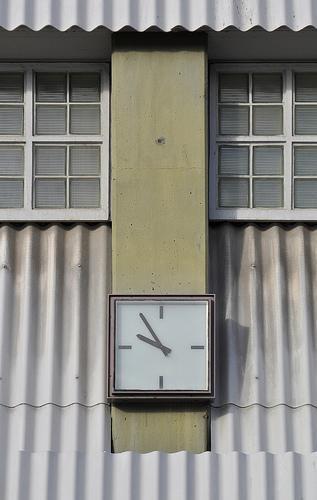How many windows are in the photo?
Give a very brief answer. 2. 